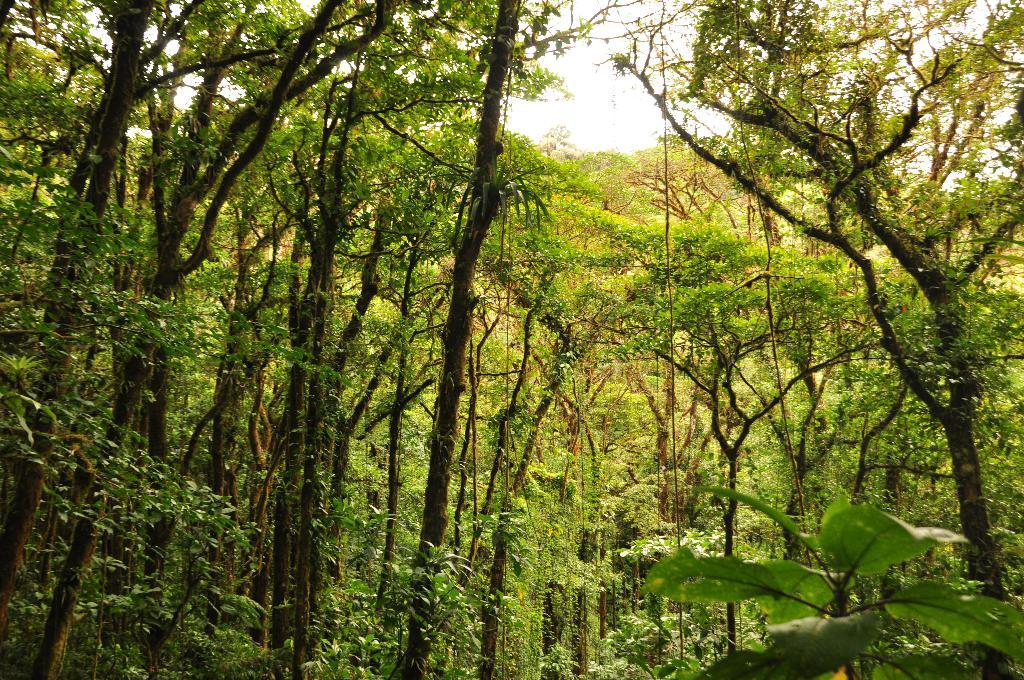What type of vegetation is present in the image? There are many trees in the image. Where might this image have been taken? The image might have been taken in a forest, given the presence of many trees. What part of the natural environment is visible in the image? The sky is visible at the top of the image. What type of development is taking place in the forest in the image? There is no indication of any development taking place in the image; it primarily features trees and the sky. Can you see any pigs or keys in the image? No, there are no pigs or keys present in the image. 